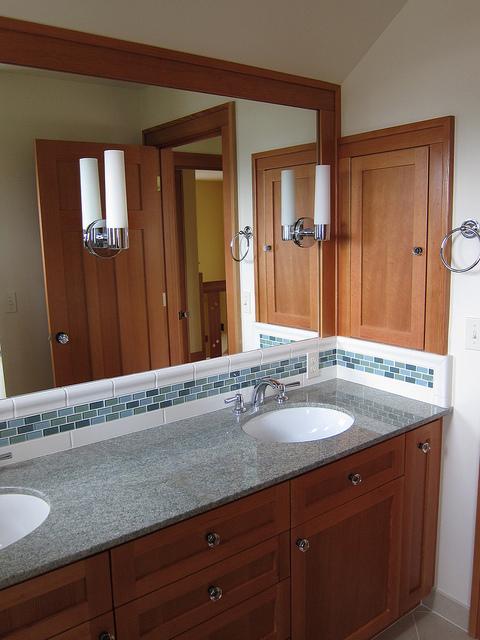What is reflected in the mirror?
Keep it brief. Door. How many sinks are in this image?
Quick response, please. 2. What material is the sink made from?
Keep it brief. Porcelain. What is the splash board made out of?
Keep it brief. Tile. 